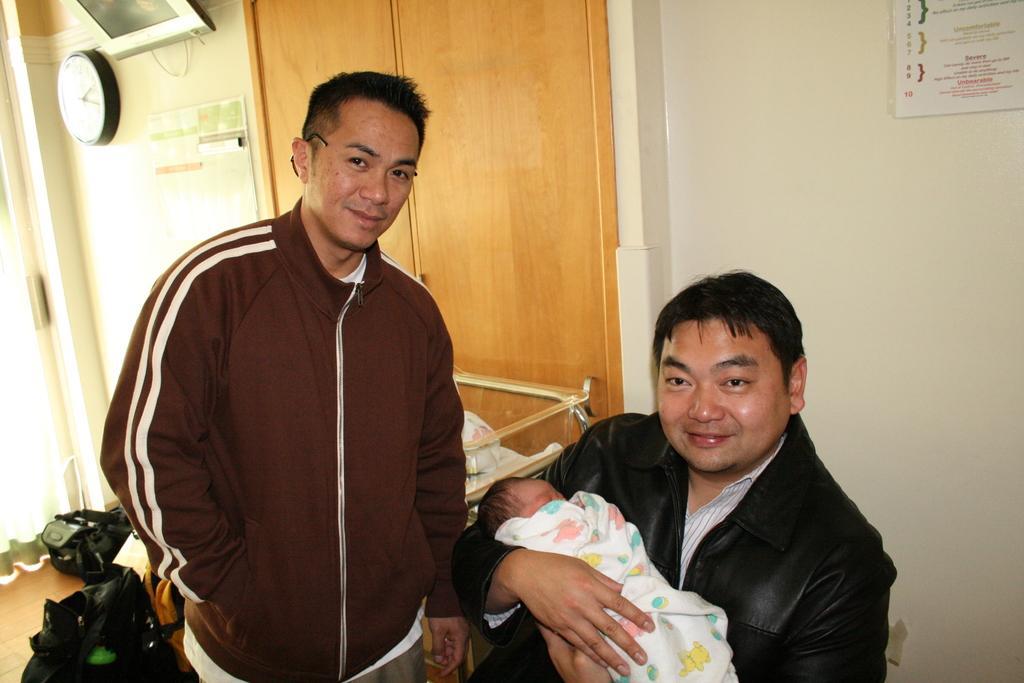How would you summarize this image in a sentence or two? In this picture we can see two men and a baby here, on the right side there is a wall, we can see a clock here, there is a paper here, we can see a photo frame here. 